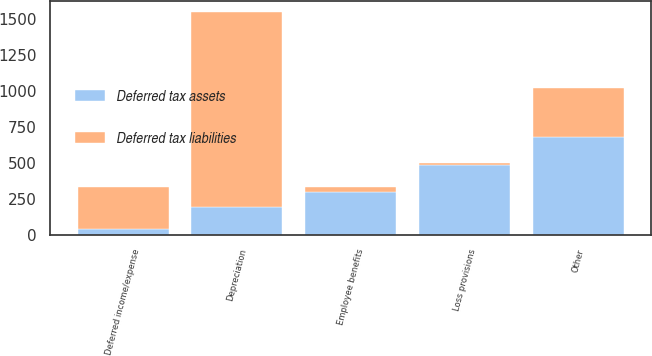Convert chart. <chart><loc_0><loc_0><loc_500><loc_500><stacked_bar_chart><ecel><fcel>Depreciation<fcel>Employee benefits<fcel>Loss provisions<fcel>Deferred income/expense<fcel>Other<nl><fcel>Deferred tax assets<fcel>194<fcel>294<fcel>486<fcel>37<fcel>680<nl><fcel>Deferred tax liabilities<fcel>1353<fcel>34<fcel>9<fcel>294<fcel>339<nl></chart> 